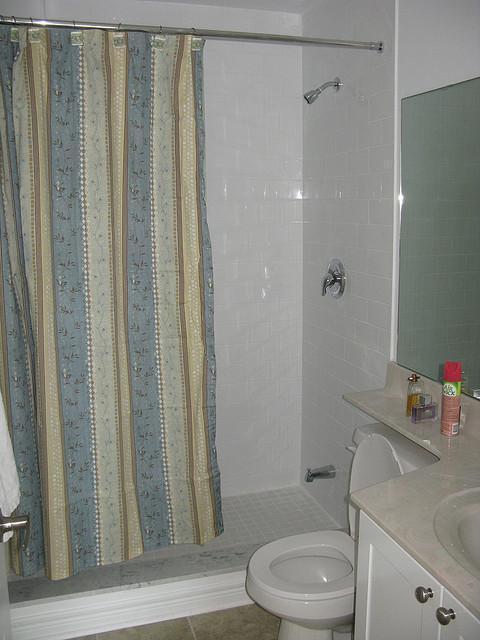What is in the can on the counter?
From the following set of four choices, select the accurate answer to respond to the question.
Options: Fake tan, paint, air freshener, hairspray. Air freshener. 